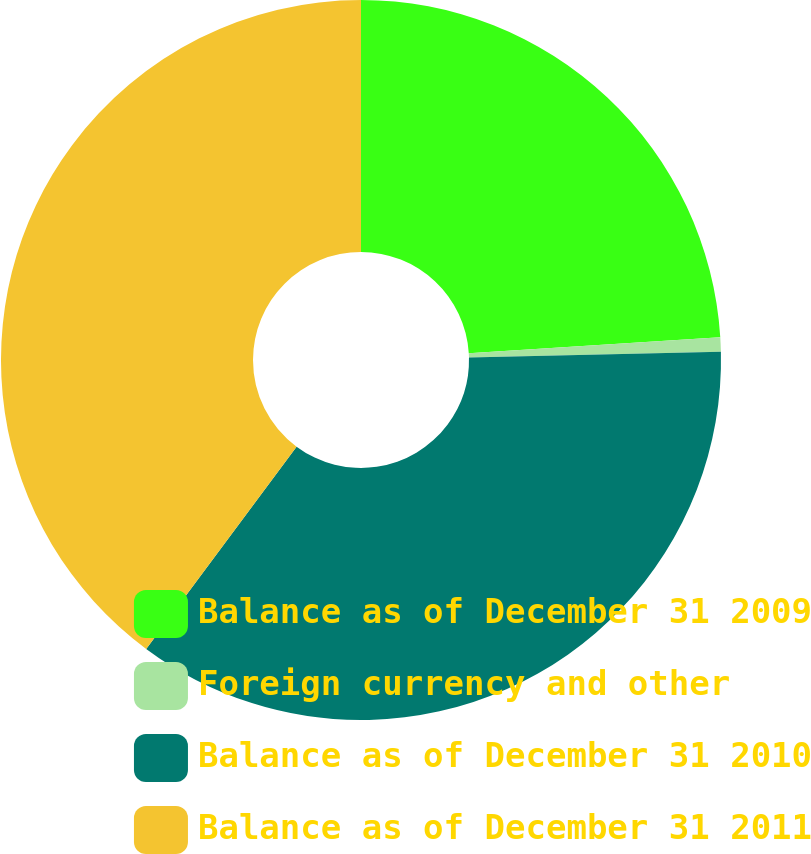Convert chart. <chart><loc_0><loc_0><loc_500><loc_500><pie_chart><fcel>Balance as of December 31 2009<fcel>Foreign currency and other<fcel>Balance as of December 31 2010<fcel>Balance as of December 31 2011<nl><fcel>23.99%<fcel>0.64%<fcel>35.54%<fcel>39.82%<nl></chart> 